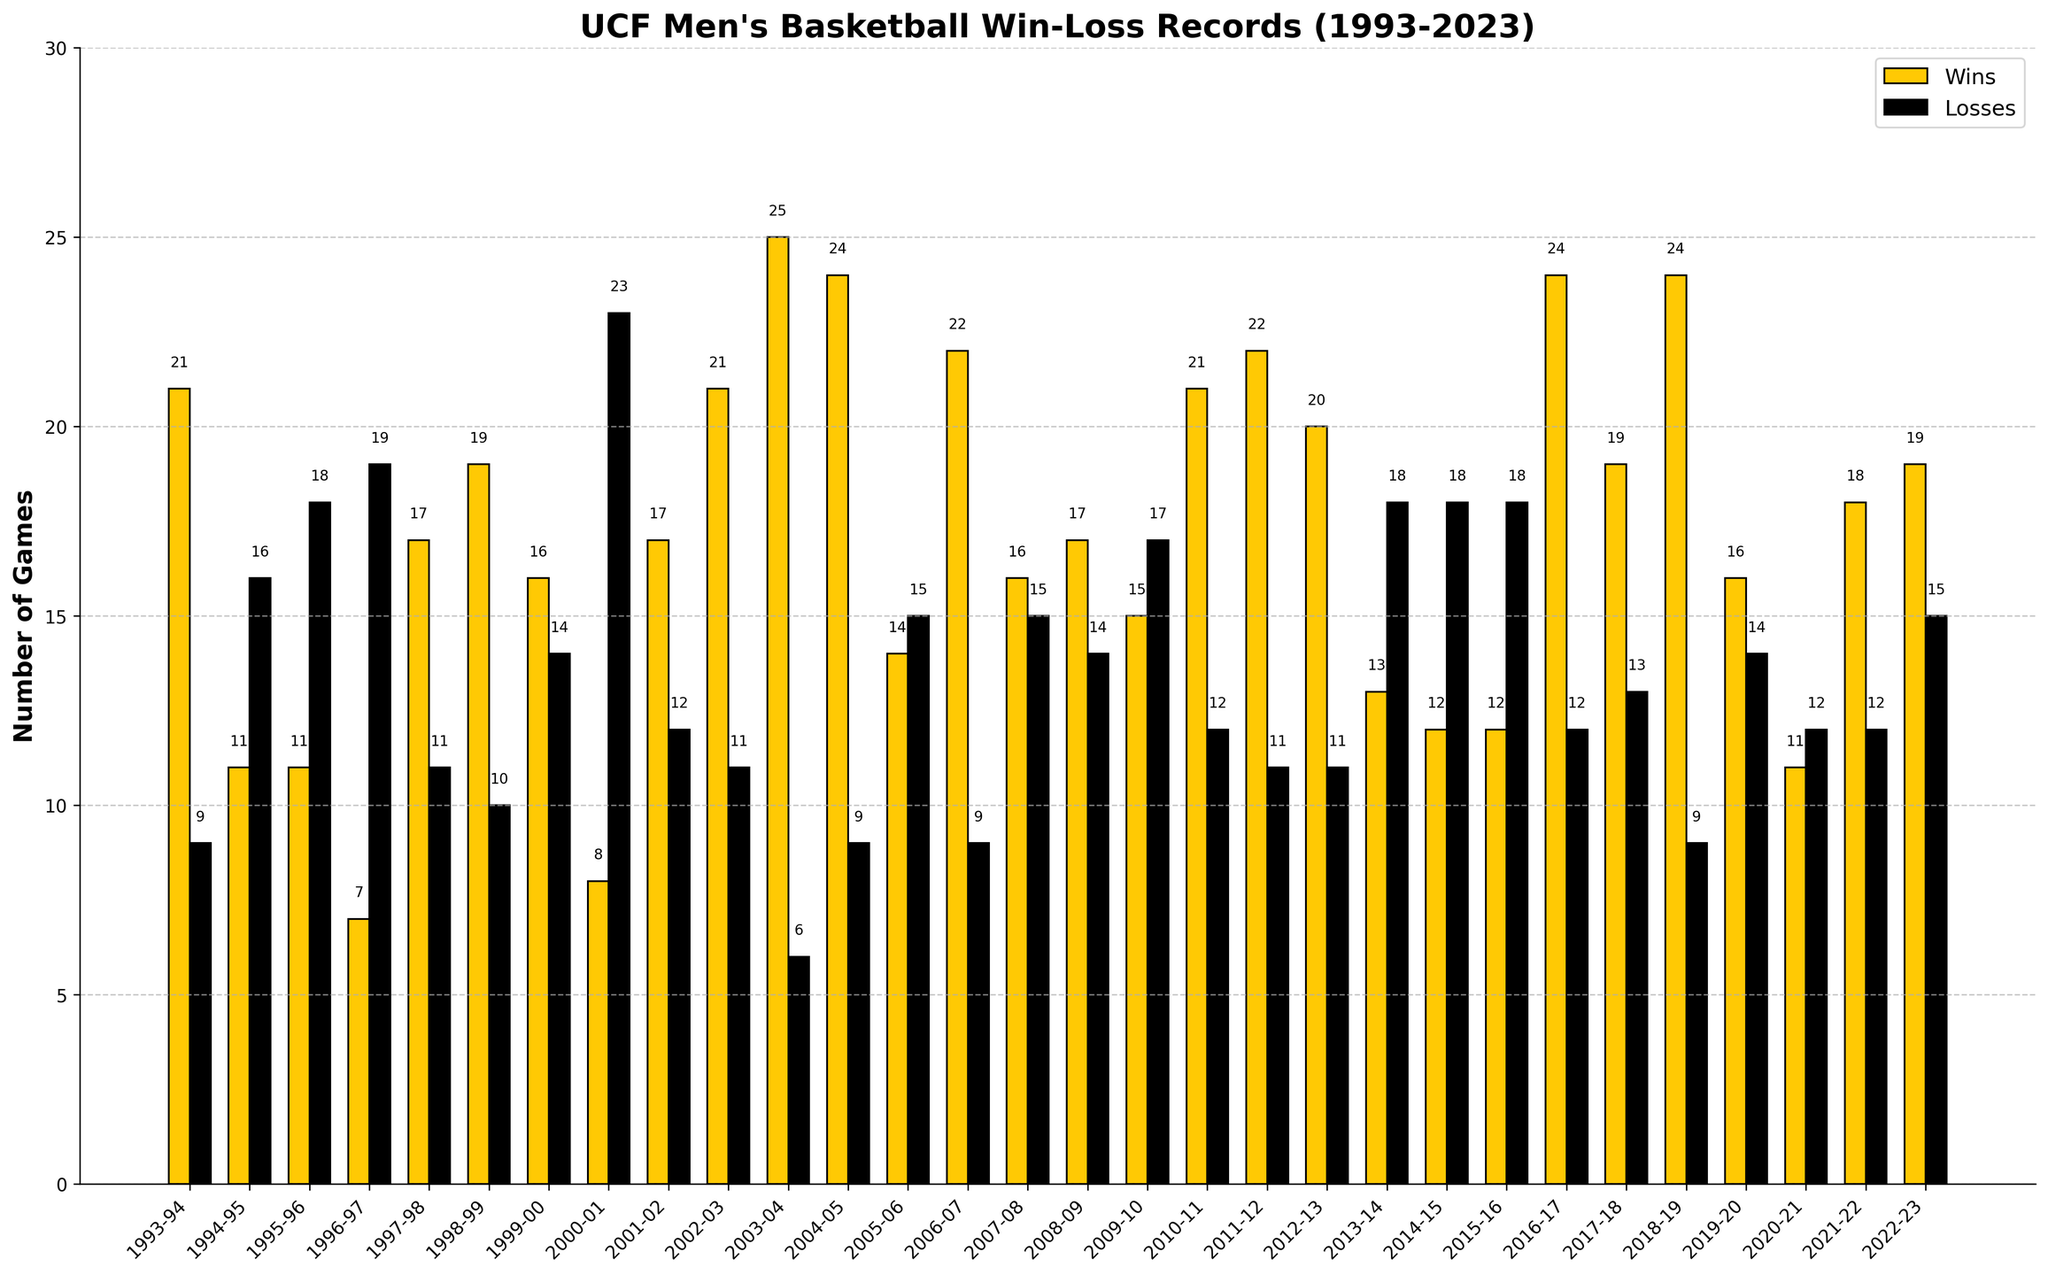Which season had the highest number of wins? By looking at the heights of the yellow bars for each season, you can see that the 2003-04 season has the tallest yellow bar, indicating the highest number of wins, which is 25.
Answer: 2003-04 Which season had the lowest number of wins? By looking at the yellow bars, the shortest bar represents the 1996-97 season with only 7 wins.
Answer: 1996-97 How do the win totals compare between the 1995-96 and 1996-97 seasons? The yellow bar for the 1995-96 season shows 11 wins, while the yellow bar for the 1996-97 season shows 7 wins. 1995-96 has more wins.
Answer: 1995-96 Which season had more losses, 2000-01 or 2019-20? Comparing the black bars for both seasons, 2000-01 has a taller black bar representing 23 losses, whereas 2019-20 has 14 losses.
Answer: 2000-01 In which season was the win-loss record closest to being even? Look for similar heights of yellow (wins) and black (losses) bars. The 2005-06 season has 14 wins and 15 losses, which are almost equal.
Answer: 2005-06 What is the total number of wins in the last five seasons shown? Sum the yellow bars for the last five seasons: 16 + 11 + 18 + 19 + 15 = 79 wins.
Answer: 79 How many seasons had more wins than losses? Count the yellow bars that are taller than the black bars. There are 19 seasons where the number of wins exceeds the number of losses.
Answer: 19 What is the win-loss differential for the 2003-04 season? For 2003-04, the yellow bar shows 25 wins and the black bar shows 6 losses. The differential is 25 - 6 = 19 games.
Answer: 19 What is the average number of wins over the 30 seasons? Sum all the yellow bars and divide by 30. Total wins = 486 (sum of all wins), so average wins = 486 / 30 = 16.2.
Answer: 16.2 Which two consecutive seasons had the biggest increase in wins? Compare the differences in the heights of the yellow bars for consecutive seasons. Between 1996-97 (7 wins) and 1997-98 (17 wins), the increase is 10 wins.
Answer: 1996-97 to 1997-98 